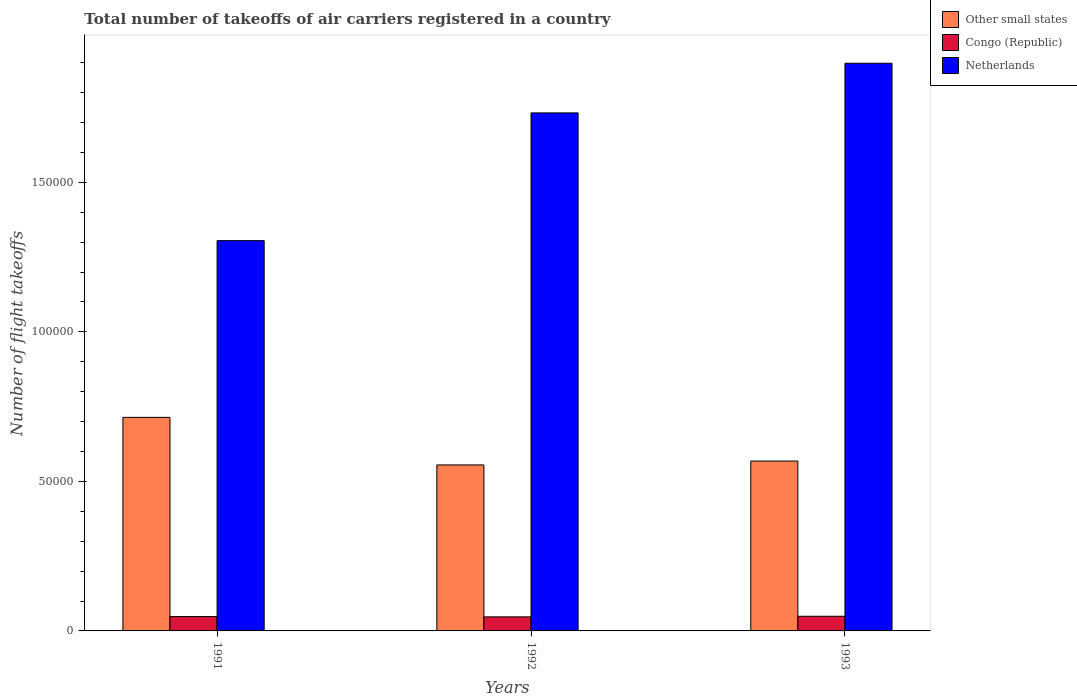How many groups of bars are there?
Provide a short and direct response. 3. Are the number of bars per tick equal to the number of legend labels?
Give a very brief answer. Yes. How many bars are there on the 1st tick from the left?
Keep it short and to the point. 3. How many bars are there on the 3rd tick from the right?
Keep it short and to the point. 3. What is the label of the 2nd group of bars from the left?
Offer a very short reply. 1992. In how many cases, is the number of bars for a given year not equal to the number of legend labels?
Offer a terse response. 0. What is the total number of flight takeoffs in Netherlands in 1993?
Your response must be concise. 1.90e+05. Across all years, what is the maximum total number of flight takeoffs in Netherlands?
Make the answer very short. 1.90e+05. Across all years, what is the minimum total number of flight takeoffs in Netherlands?
Offer a terse response. 1.30e+05. In which year was the total number of flight takeoffs in Netherlands minimum?
Offer a terse response. 1991. What is the total total number of flight takeoffs in Other small states in the graph?
Offer a very short reply. 1.84e+05. What is the difference between the total number of flight takeoffs in Netherlands in 1992 and that in 1993?
Provide a succinct answer. -1.66e+04. What is the difference between the total number of flight takeoffs in Congo (Republic) in 1993 and the total number of flight takeoffs in Netherlands in 1991?
Provide a succinct answer. -1.26e+05. What is the average total number of flight takeoffs in Netherlands per year?
Your response must be concise. 1.64e+05. In the year 1993, what is the difference between the total number of flight takeoffs in Congo (Republic) and total number of flight takeoffs in Other small states?
Make the answer very short. -5.19e+04. What is the ratio of the total number of flight takeoffs in Congo (Republic) in 1991 to that in 1992?
Keep it short and to the point. 1.02. What is the difference between the highest and the second highest total number of flight takeoffs in Netherlands?
Provide a succinct answer. 1.66e+04. What is the difference between the highest and the lowest total number of flight takeoffs in Netherlands?
Make the answer very short. 5.93e+04. What does the 2nd bar from the left in 1992 represents?
Ensure brevity in your answer.  Congo (Republic). What does the 3rd bar from the right in 1992 represents?
Keep it short and to the point. Other small states. Is it the case that in every year, the sum of the total number of flight takeoffs in Other small states and total number of flight takeoffs in Congo (Republic) is greater than the total number of flight takeoffs in Netherlands?
Keep it short and to the point. No. Are all the bars in the graph horizontal?
Your answer should be compact. No. How many years are there in the graph?
Your response must be concise. 3. Are the values on the major ticks of Y-axis written in scientific E-notation?
Offer a terse response. No. Does the graph contain any zero values?
Ensure brevity in your answer.  No. What is the title of the graph?
Make the answer very short. Total number of takeoffs of air carriers registered in a country. Does "New Zealand" appear as one of the legend labels in the graph?
Ensure brevity in your answer.  No. What is the label or title of the Y-axis?
Your response must be concise. Number of flight takeoffs. What is the Number of flight takeoffs in Other small states in 1991?
Keep it short and to the point. 7.14e+04. What is the Number of flight takeoffs in Congo (Republic) in 1991?
Your answer should be very brief. 4800. What is the Number of flight takeoffs of Netherlands in 1991?
Offer a terse response. 1.30e+05. What is the Number of flight takeoffs in Other small states in 1992?
Provide a short and direct response. 5.55e+04. What is the Number of flight takeoffs of Congo (Republic) in 1992?
Offer a very short reply. 4700. What is the Number of flight takeoffs in Netherlands in 1992?
Keep it short and to the point. 1.73e+05. What is the Number of flight takeoffs in Other small states in 1993?
Ensure brevity in your answer.  5.68e+04. What is the Number of flight takeoffs in Congo (Republic) in 1993?
Provide a succinct answer. 4900. What is the Number of flight takeoffs of Netherlands in 1993?
Your answer should be compact. 1.90e+05. Across all years, what is the maximum Number of flight takeoffs in Other small states?
Provide a succinct answer. 7.14e+04. Across all years, what is the maximum Number of flight takeoffs of Congo (Republic)?
Provide a short and direct response. 4900. Across all years, what is the maximum Number of flight takeoffs of Netherlands?
Offer a terse response. 1.90e+05. Across all years, what is the minimum Number of flight takeoffs of Other small states?
Offer a very short reply. 5.55e+04. Across all years, what is the minimum Number of flight takeoffs of Congo (Republic)?
Your answer should be very brief. 4700. Across all years, what is the minimum Number of flight takeoffs of Netherlands?
Ensure brevity in your answer.  1.30e+05. What is the total Number of flight takeoffs of Other small states in the graph?
Your answer should be compact. 1.84e+05. What is the total Number of flight takeoffs in Congo (Republic) in the graph?
Offer a very short reply. 1.44e+04. What is the total Number of flight takeoffs in Netherlands in the graph?
Your answer should be very brief. 4.94e+05. What is the difference between the Number of flight takeoffs of Other small states in 1991 and that in 1992?
Keep it short and to the point. 1.59e+04. What is the difference between the Number of flight takeoffs of Netherlands in 1991 and that in 1992?
Your answer should be compact. -4.27e+04. What is the difference between the Number of flight takeoffs in Other small states in 1991 and that in 1993?
Your answer should be very brief. 1.46e+04. What is the difference between the Number of flight takeoffs in Congo (Republic) in 1991 and that in 1993?
Give a very brief answer. -100. What is the difference between the Number of flight takeoffs of Netherlands in 1991 and that in 1993?
Give a very brief answer. -5.93e+04. What is the difference between the Number of flight takeoffs in Other small states in 1992 and that in 1993?
Provide a succinct answer. -1300. What is the difference between the Number of flight takeoffs in Congo (Republic) in 1992 and that in 1993?
Offer a very short reply. -200. What is the difference between the Number of flight takeoffs in Netherlands in 1992 and that in 1993?
Offer a terse response. -1.66e+04. What is the difference between the Number of flight takeoffs of Other small states in 1991 and the Number of flight takeoffs of Congo (Republic) in 1992?
Offer a very short reply. 6.67e+04. What is the difference between the Number of flight takeoffs of Other small states in 1991 and the Number of flight takeoffs of Netherlands in 1992?
Offer a very short reply. -1.02e+05. What is the difference between the Number of flight takeoffs in Congo (Republic) in 1991 and the Number of flight takeoffs in Netherlands in 1992?
Provide a succinct answer. -1.68e+05. What is the difference between the Number of flight takeoffs of Other small states in 1991 and the Number of flight takeoffs of Congo (Republic) in 1993?
Offer a terse response. 6.65e+04. What is the difference between the Number of flight takeoffs in Other small states in 1991 and the Number of flight takeoffs in Netherlands in 1993?
Offer a very short reply. -1.18e+05. What is the difference between the Number of flight takeoffs of Congo (Republic) in 1991 and the Number of flight takeoffs of Netherlands in 1993?
Your answer should be compact. -1.85e+05. What is the difference between the Number of flight takeoffs in Other small states in 1992 and the Number of flight takeoffs in Congo (Republic) in 1993?
Provide a short and direct response. 5.06e+04. What is the difference between the Number of flight takeoffs in Other small states in 1992 and the Number of flight takeoffs in Netherlands in 1993?
Keep it short and to the point. -1.34e+05. What is the difference between the Number of flight takeoffs of Congo (Republic) in 1992 and the Number of flight takeoffs of Netherlands in 1993?
Provide a succinct answer. -1.85e+05. What is the average Number of flight takeoffs of Other small states per year?
Offer a very short reply. 6.12e+04. What is the average Number of flight takeoffs of Congo (Republic) per year?
Provide a short and direct response. 4800. What is the average Number of flight takeoffs in Netherlands per year?
Your answer should be very brief. 1.64e+05. In the year 1991, what is the difference between the Number of flight takeoffs of Other small states and Number of flight takeoffs of Congo (Republic)?
Ensure brevity in your answer.  6.66e+04. In the year 1991, what is the difference between the Number of flight takeoffs of Other small states and Number of flight takeoffs of Netherlands?
Your answer should be compact. -5.91e+04. In the year 1991, what is the difference between the Number of flight takeoffs in Congo (Republic) and Number of flight takeoffs in Netherlands?
Offer a terse response. -1.26e+05. In the year 1992, what is the difference between the Number of flight takeoffs in Other small states and Number of flight takeoffs in Congo (Republic)?
Offer a very short reply. 5.08e+04. In the year 1992, what is the difference between the Number of flight takeoffs of Other small states and Number of flight takeoffs of Netherlands?
Provide a short and direct response. -1.18e+05. In the year 1992, what is the difference between the Number of flight takeoffs in Congo (Republic) and Number of flight takeoffs in Netherlands?
Provide a short and direct response. -1.68e+05. In the year 1993, what is the difference between the Number of flight takeoffs of Other small states and Number of flight takeoffs of Congo (Republic)?
Your answer should be very brief. 5.19e+04. In the year 1993, what is the difference between the Number of flight takeoffs of Other small states and Number of flight takeoffs of Netherlands?
Provide a succinct answer. -1.33e+05. In the year 1993, what is the difference between the Number of flight takeoffs of Congo (Republic) and Number of flight takeoffs of Netherlands?
Ensure brevity in your answer.  -1.85e+05. What is the ratio of the Number of flight takeoffs in Other small states in 1991 to that in 1992?
Provide a succinct answer. 1.29. What is the ratio of the Number of flight takeoffs of Congo (Republic) in 1991 to that in 1992?
Your response must be concise. 1.02. What is the ratio of the Number of flight takeoffs in Netherlands in 1991 to that in 1992?
Offer a very short reply. 0.75. What is the ratio of the Number of flight takeoffs in Other small states in 1991 to that in 1993?
Ensure brevity in your answer.  1.26. What is the ratio of the Number of flight takeoffs of Congo (Republic) in 1991 to that in 1993?
Offer a terse response. 0.98. What is the ratio of the Number of flight takeoffs of Netherlands in 1991 to that in 1993?
Provide a succinct answer. 0.69. What is the ratio of the Number of flight takeoffs of Other small states in 1992 to that in 1993?
Ensure brevity in your answer.  0.98. What is the ratio of the Number of flight takeoffs of Congo (Republic) in 1992 to that in 1993?
Provide a short and direct response. 0.96. What is the ratio of the Number of flight takeoffs in Netherlands in 1992 to that in 1993?
Offer a terse response. 0.91. What is the difference between the highest and the second highest Number of flight takeoffs in Other small states?
Give a very brief answer. 1.46e+04. What is the difference between the highest and the second highest Number of flight takeoffs in Netherlands?
Make the answer very short. 1.66e+04. What is the difference between the highest and the lowest Number of flight takeoffs of Other small states?
Keep it short and to the point. 1.59e+04. What is the difference between the highest and the lowest Number of flight takeoffs in Congo (Republic)?
Your answer should be very brief. 200. What is the difference between the highest and the lowest Number of flight takeoffs of Netherlands?
Ensure brevity in your answer.  5.93e+04. 